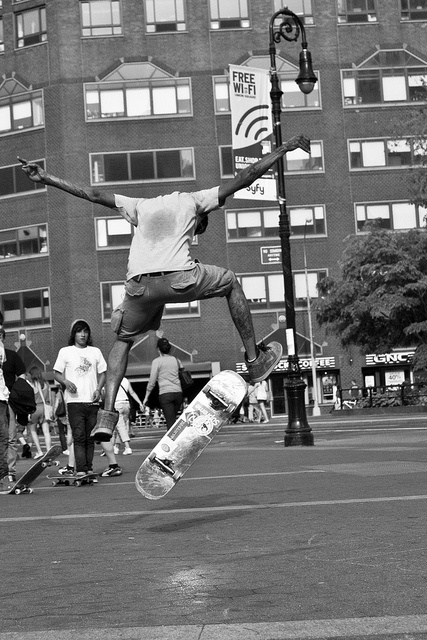Describe the objects in this image and their specific colors. I can see people in darkgray, gray, black, and lightgray tones, skateboard in darkgray, white, gray, and black tones, people in darkgray, black, white, and gray tones, people in darkgray, black, gray, and lightgray tones, and people in darkgray, black, gray, and lightgray tones in this image. 